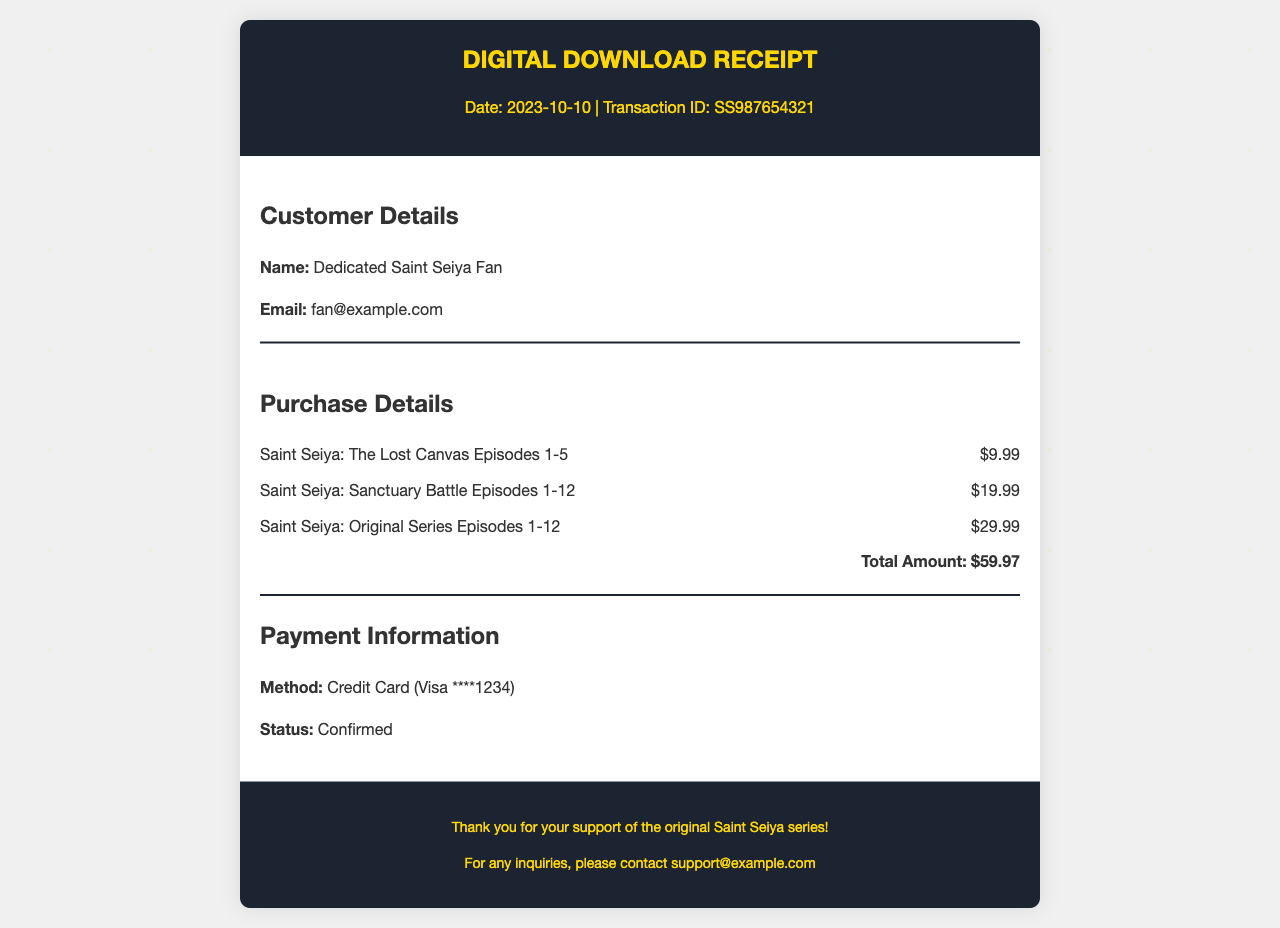What is the date of the receipt? The receipt date is mentioned at the top in the receipt header section as 2023-10-10.
Answer: 2023-10-10 What is the transaction ID? The transaction ID is presented right below the date in the receipt header.
Answer: SS987654321 Who is the customer? The customer name is provided in the customer details section.
Answer: Dedicated Saint Seiya Fan What is the total amount of the purchase? The total amount is calculated from the listed purchases and is found in the purchase details section.
Answer: $59.97 What payment method was used? The payment method is specified in the payment information section.
Answer: Credit Card (Visa ****1234) How many episodes are in the Saint Seiya: Original Series purchase? The number of episodes is mentioned along with the title in the purchase details.
Answer: 12 How much did the Saint Seiya: The Lost Canvas Episodes cost? The cost for this item is listed in the purchase details section.
Answer: $9.99 What is the status of the payment? The payment status is indicated in the payment information section.
Answer: Confirmed How many episodes are included in the Sanctuary Battle purchase? The number of episodes is mentioned directly with the title in the purchase details.
Answer: 12 